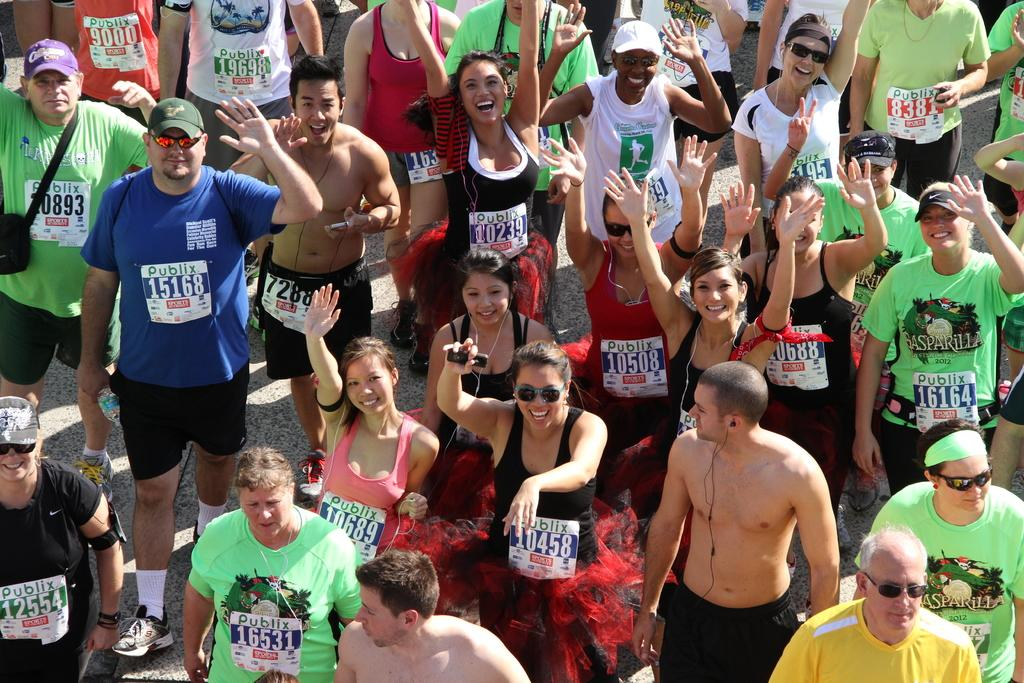How many people are in the image? There is a group of persons in the image. Where are the persons located in the image? The group of persons is on the road. Reasoning: Let' Let's think step by step in order to produce the conversation. We start by identifying the main subject in the image, which is the group of persons. Then, we expand the conversation to include the location of the group, which is on the road. Each question is designed to elicit a specific detail about the image that is known from the provided facts. Absurd Question/Answer: What color is the crayon being used by the person in the image? There is no crayon present in the image. What type of architectural structure can be seen in the background of the image? The provided facts do not mention any architectural structures in the background. 